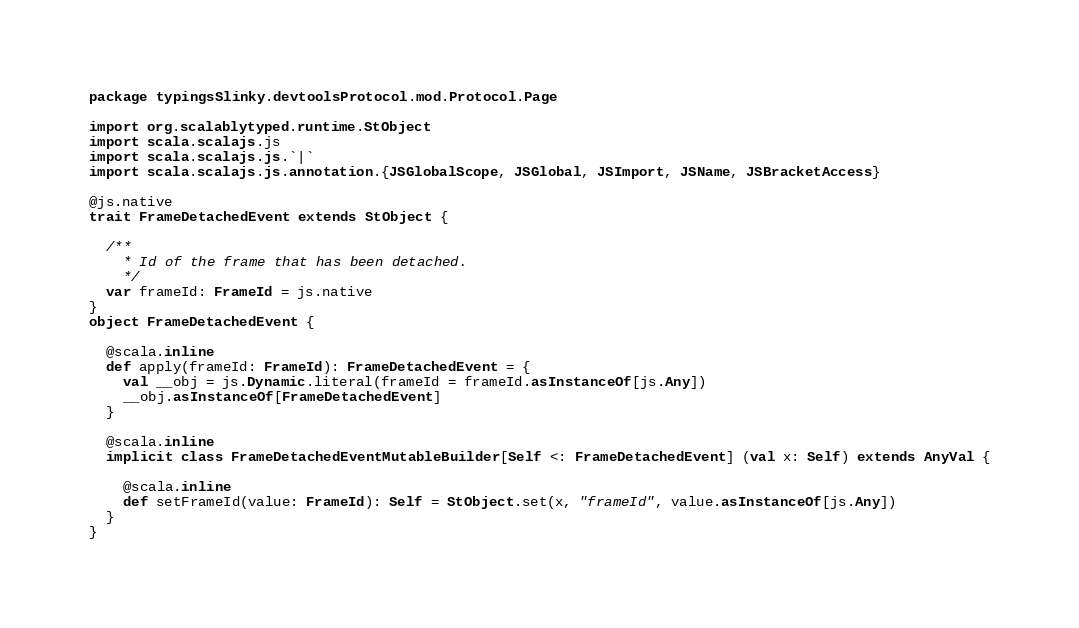<code> <loc_0><loc_0><loc_500><loc_500><_Scala_>package typingsSlinky.devtoolsProtocol.mod.Protocol.Page

import org.scalablytyped.runtime.StObject
import scala.scalajs.js
import scala.scalajs.js.`|`
import scala.scalajs.js.annotation.{JSGlobalScope, JSGlobal, JSImport, JSName, JSBracketAccess}

@js.native
trait FrameDetachedEvent extends StObject {
  
  /**
    * Id of the frame that has been detached.
    */
  var frameId: FrameId = js.native
}
object FrameDetachedEvent {
  
  @scala.inline
  def apply(frameId: FrameId): FrameDetachedEvent = {
    val __obj = js.Dynamic.literal(frameId = frameId.asInstanceOf[js.Any])
    __obj.asInstanceOf[FrameDetachedEvent]
  }
  
  @scala.inline
  implicit class FrameDetachedEventMutableBuilder[Self <: FrameDetachedEvent] (val x: Self) extends AnyVal {
    
    @scala.inline
    def setFrameId(value: FrameId): Self = StObject.set(x, "frameId", value.asInstanceOf[js.Any])
  }
}
</code> 